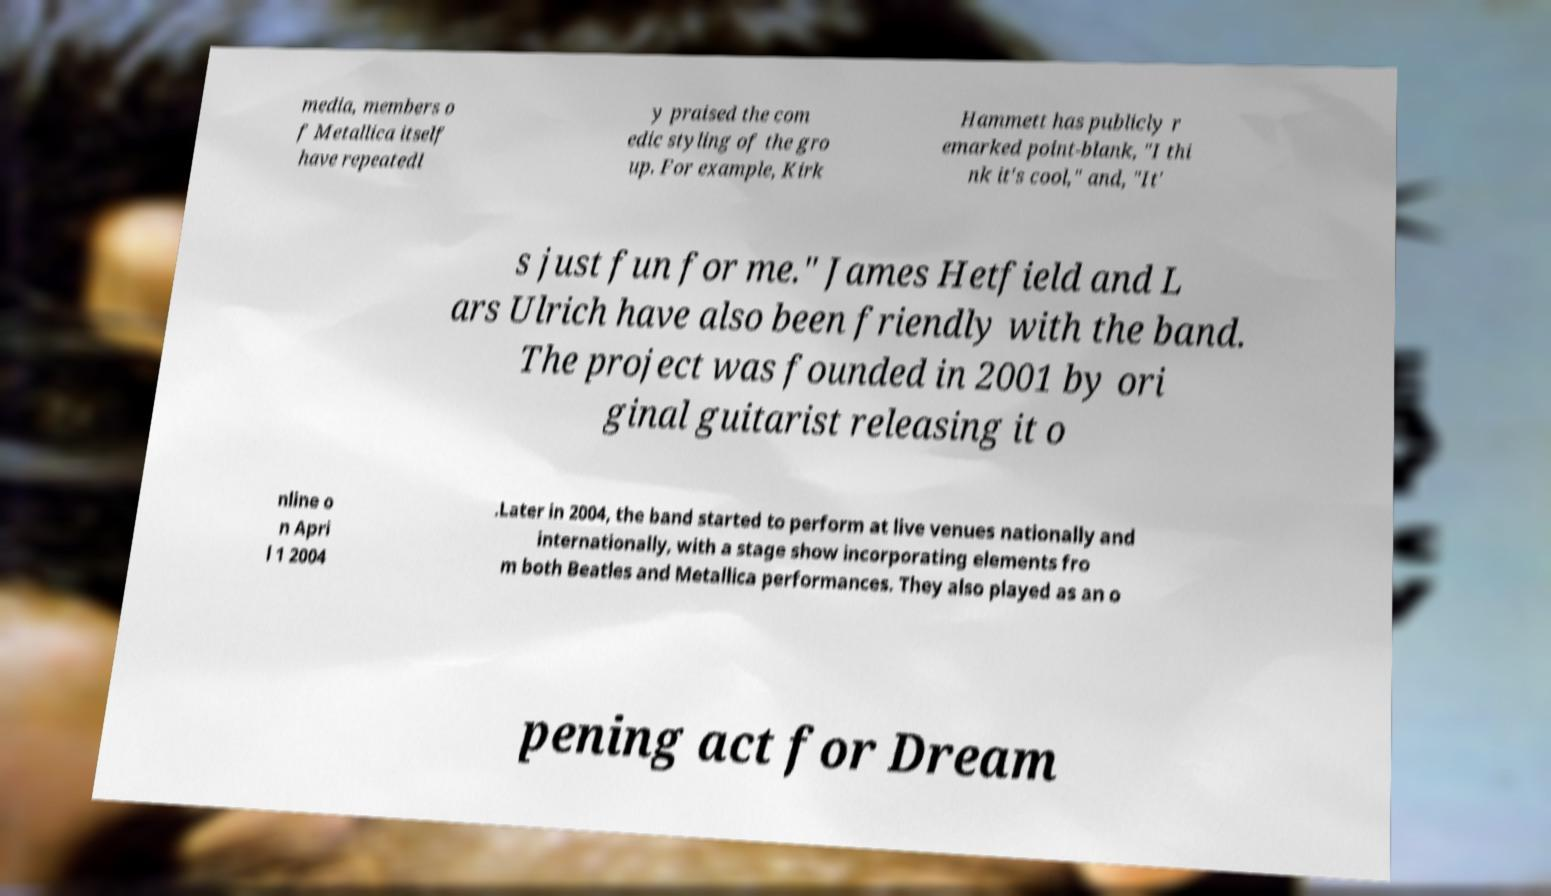Could you extract and type out the text from this image? media, members o f Metallica itself have repeatedl y praised the com edic styling of the gro up. For example, Kirk Hammett has publicly r emarked point-blank, "I thi nk it's cool," and, "It' s just fun for me." James Hetfield and L ars Ulrich have also been friendly with the band. The project was founded in 2001 by ori ginal guitarist releasing it o nline o n Apri l 1 2004 .Later in 2004, the band started to perform at live venues nationally and internationally, with a stage show incorporating elements fro m both Beatles and Metallica performances. They also played as an o pening act for Dream 